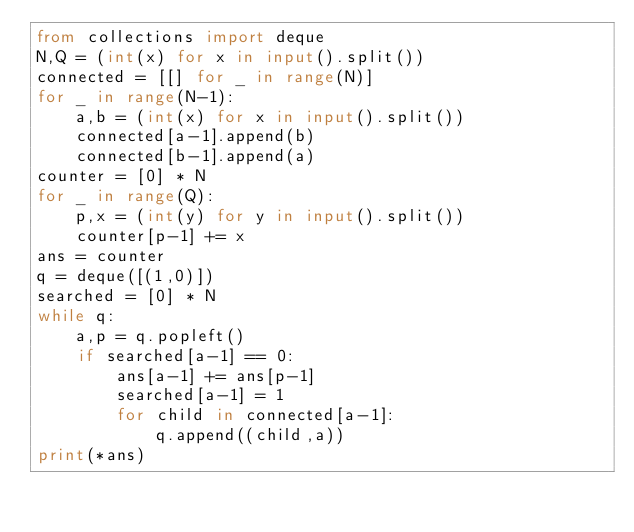Convert code to text. <code><loc_0><loc_0><loc_500><loc_500><_Python_>from collections import deque
N,Q = (int(x) for x in input().split())
connected = [[] for _ in range(N)]
for _ in range(N-1):
    a,b = (int(x) for x in input().split())
    connected[a-1].append(b)
    connected[b-1].append(a)
counter = [0] * N
for _ in range(Q):
    p,x = (int(y) for y in input().split())
    counter[p-1] += x
ans = counter
q = deque([(1,0)])
searched = [0] * N
while q:
    a,p = q.popleft()
    if searched[a-1] == 0:
        ans[a-1] += ans[p-1]
        searched[a-1] = 1
        for child in connected[a-1]:
            q.append((child,a))
print(*ans)</code> 